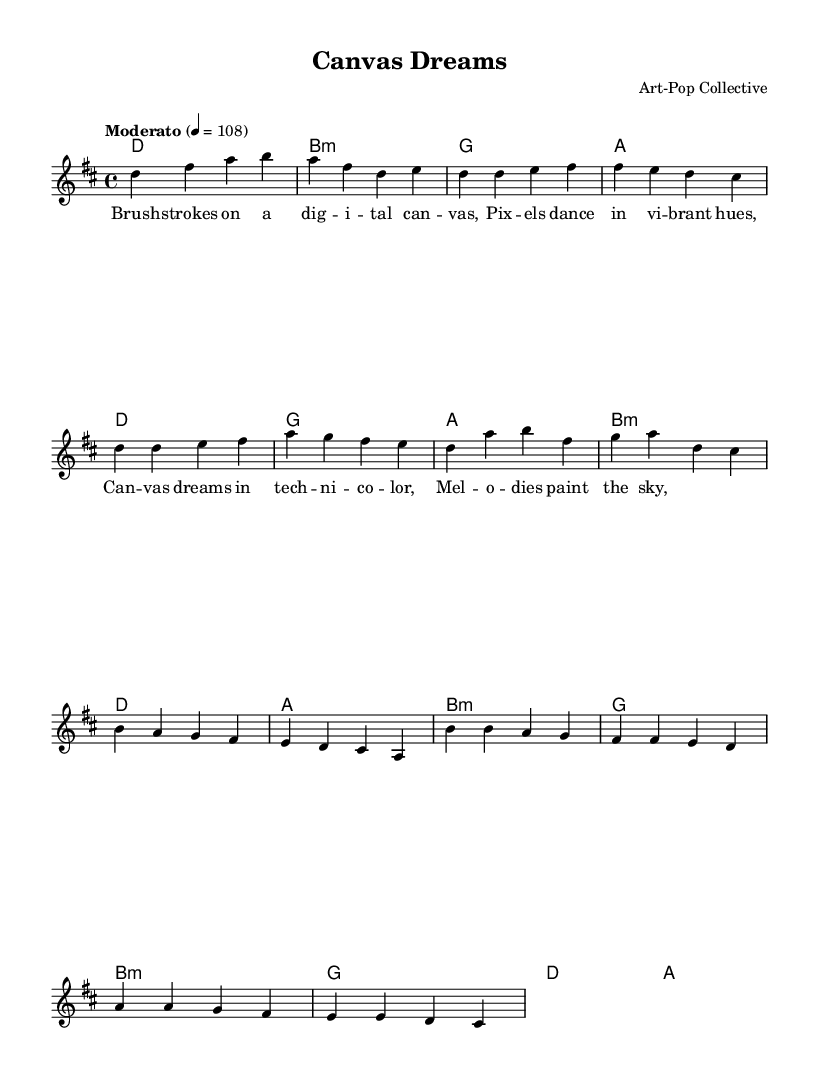What is the key signature of this music? The key signature is D major, which has two sharps (F# and C#). This can be identified by looking at the key signature placed at the beginning of the staff, which indicates the note alterations.
Answer: D major What is the time signature of the piece? The time signature is 4/4, which means there are four beats in each measure and a quarter note gets one beat. This can be determined by examining the time signature notation at the beginning of the score.
Answer: 4/4 What is the tempo marking of this music? The tempo marking is Moderato, which suggests a moderate pace. The specific metronome marking of 4 equals 108 gives a precise speed for performance. This information is shown in the tempo directive included in the header.
Answer: Moderato How many measures are in the melody section? There are twenty measures in the melody section. By counting each measure indicated by the vertical bar lines, you can determine the total number.
Answer: 20 What chord is played during the bridge section? The bridge section uses the B minor chord as indicated in the chord changes provided within that framework. This can be recognized while analyzing the chord symbols aligned with the corresponding melody notes.
Answer: B minor What are the lyrics for the chorus section? The lyrics for the chorus are "Canvas dreams in technicolor, Melodies paint the sky." This can be identified by looking at the lyric mode section written under the relevant voice part.
Answer: Canvas dreams in technicolor, Melodies paint the sky How many times does the note "D" appear in the first verse? The note "D" appears six times in the first verse. This can be counted by visually scanning the melody notes within that section and tallying each instance of "D."
Answer: 6 